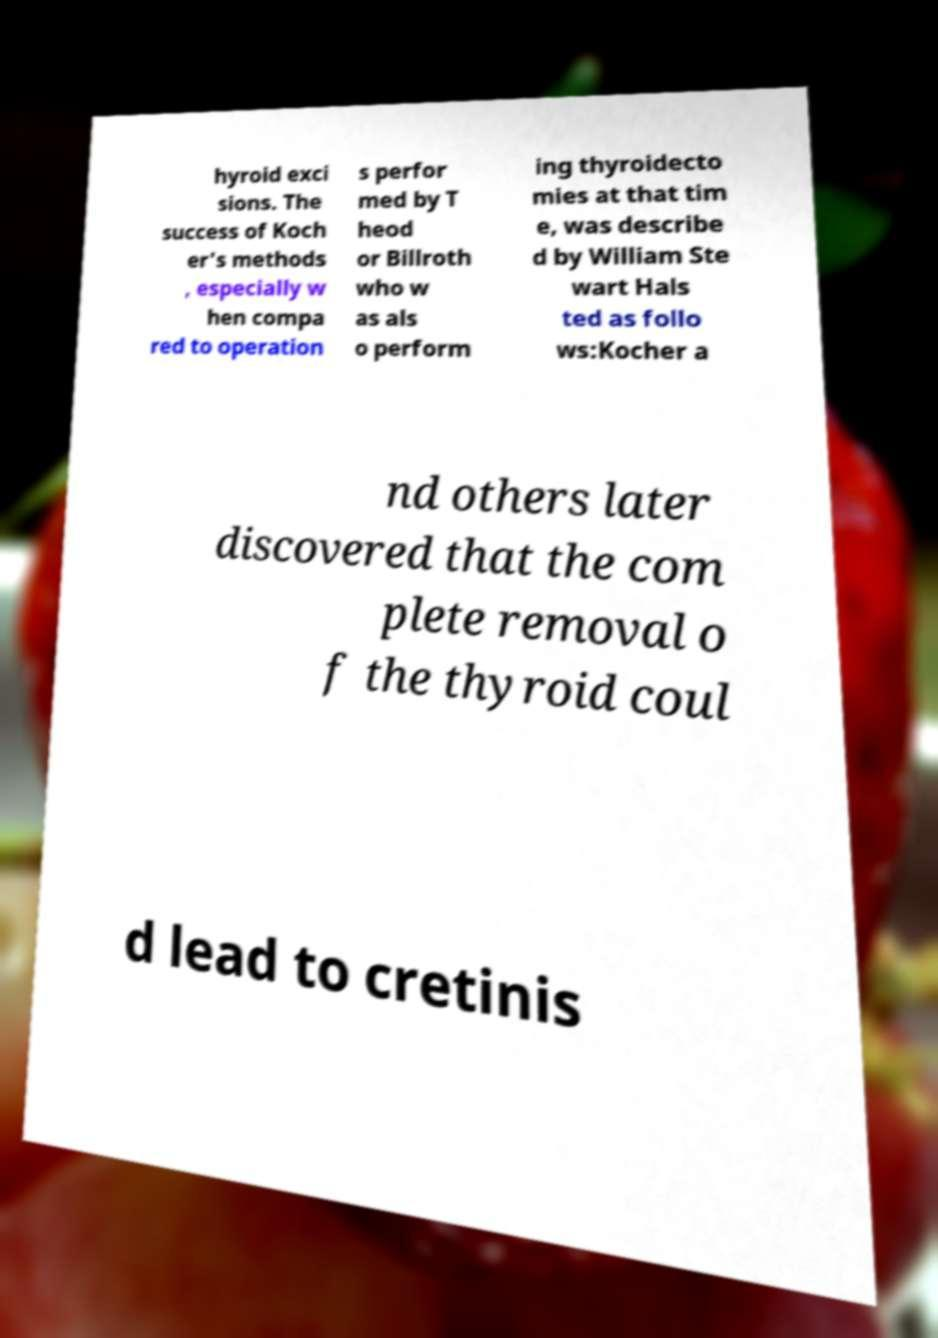What messages or text are displayed in this image? I need them in a readable, typed format. hyroid exci sions. The success of Koch er's methods , especially w hen compa red to operation s perfor med by T heod or Billroth who w as als o perform ing thyroidecto mies at that tim e, was describe d by William Ste wart Hals ted as follo ws:Kocher a nd others later discovered that the com plete removal o f the thyroid coul d lead to cretinis 